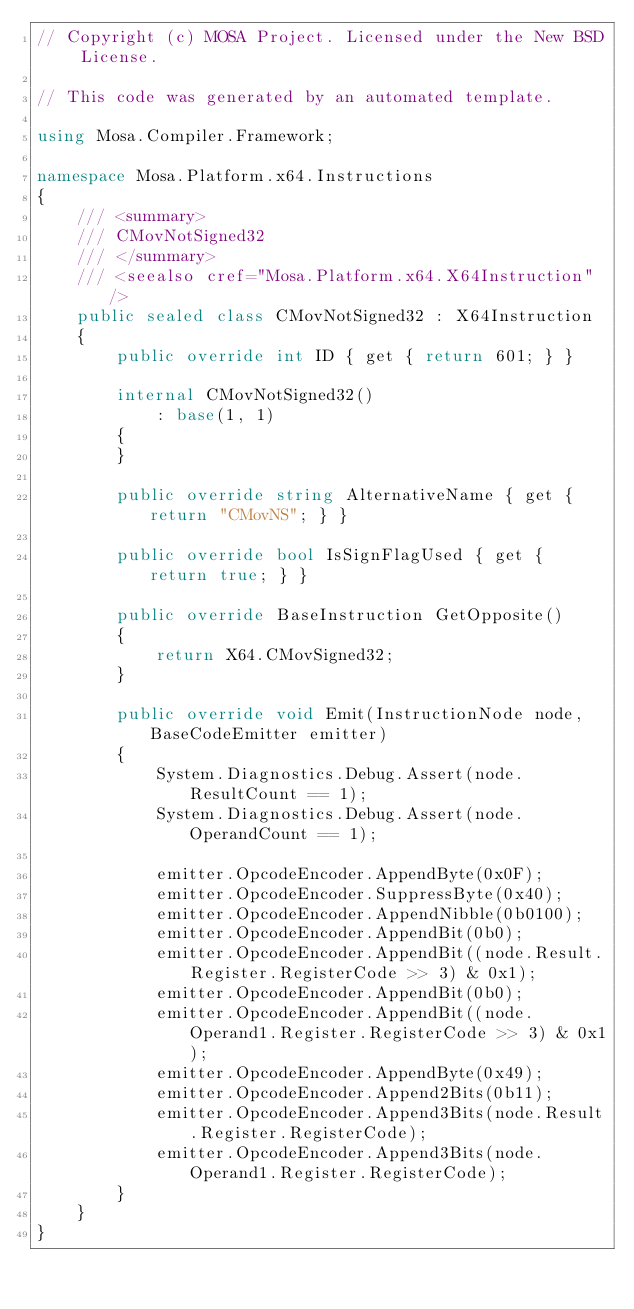<code> <loc_0><loc_0><loc_500><loc_500><_C#_>// Copyright (c) MOSA Project. Licensed under the New BSD License.

// This code was generated by an automated template.

using Mosa.Compiler.Framework;

namespace Mosa.Platform.x64.Instructions
{
	/// <summary>
	/// CMovNotSigned32
	/// </summary>
	/// <seealso cref="Mosa.Platform.x64.X64Instruction" />
	public sealed class CMovNotSigned32 : X64Instruction
	{
		public override int ID { get { return 601; } }

		internal CMovNotSigned32()
			: base(1, 1)
		{
		}

		public override string AlternativeName { get { return "CMovNS"; } }

		public override bool IsSignFlagUsed { get { return true; } }

		public override BaseInstruction GetOpposite()
		{
			return X64.CMovSigned32;
		}

		public override void Emit(InstructionNode node, BaseCodeEmitter emitter)
		{
			System.Diagnostics.Debug.Assert(node.ResultCount == 1);
			System.Diagnostics.Debug.Assert(node.OperandCount == 1);

			emitter.OpcodeEncoder.AppendByte(0x0F);
			emitter.OpcodeEncoder.SuppressByte(0x40);
			emitter.OpcodeEncoder.AppendNibble(0b0100);
			emitter.OpcodeEncoder.AppendBit(0b0);
			emitter.OpcodeEncoder.AppendBit((node.Result.Register.RegisterCode >> 3) & 0x1);
			emitter.OpcodeEncoder.AppendBit(0b0);
			emitter.OpcodeEncoder.AppendBit((node.Operand1.Register.RegisterCode >> 3) & 0x1);
			emitter.OpcodeEncoder.AppendByte(0x49);
			emitter.OpcodeEncoder.Append2Bits(0b11);
			emitter.OpcodeEncoder.Append3Bits(node.Result.Register.RegisterCode);
			emitter.OpcodeEncoder.Append3Bits(node.Operand1.Register.RegisterCode);
		}
	}
}
</code> 